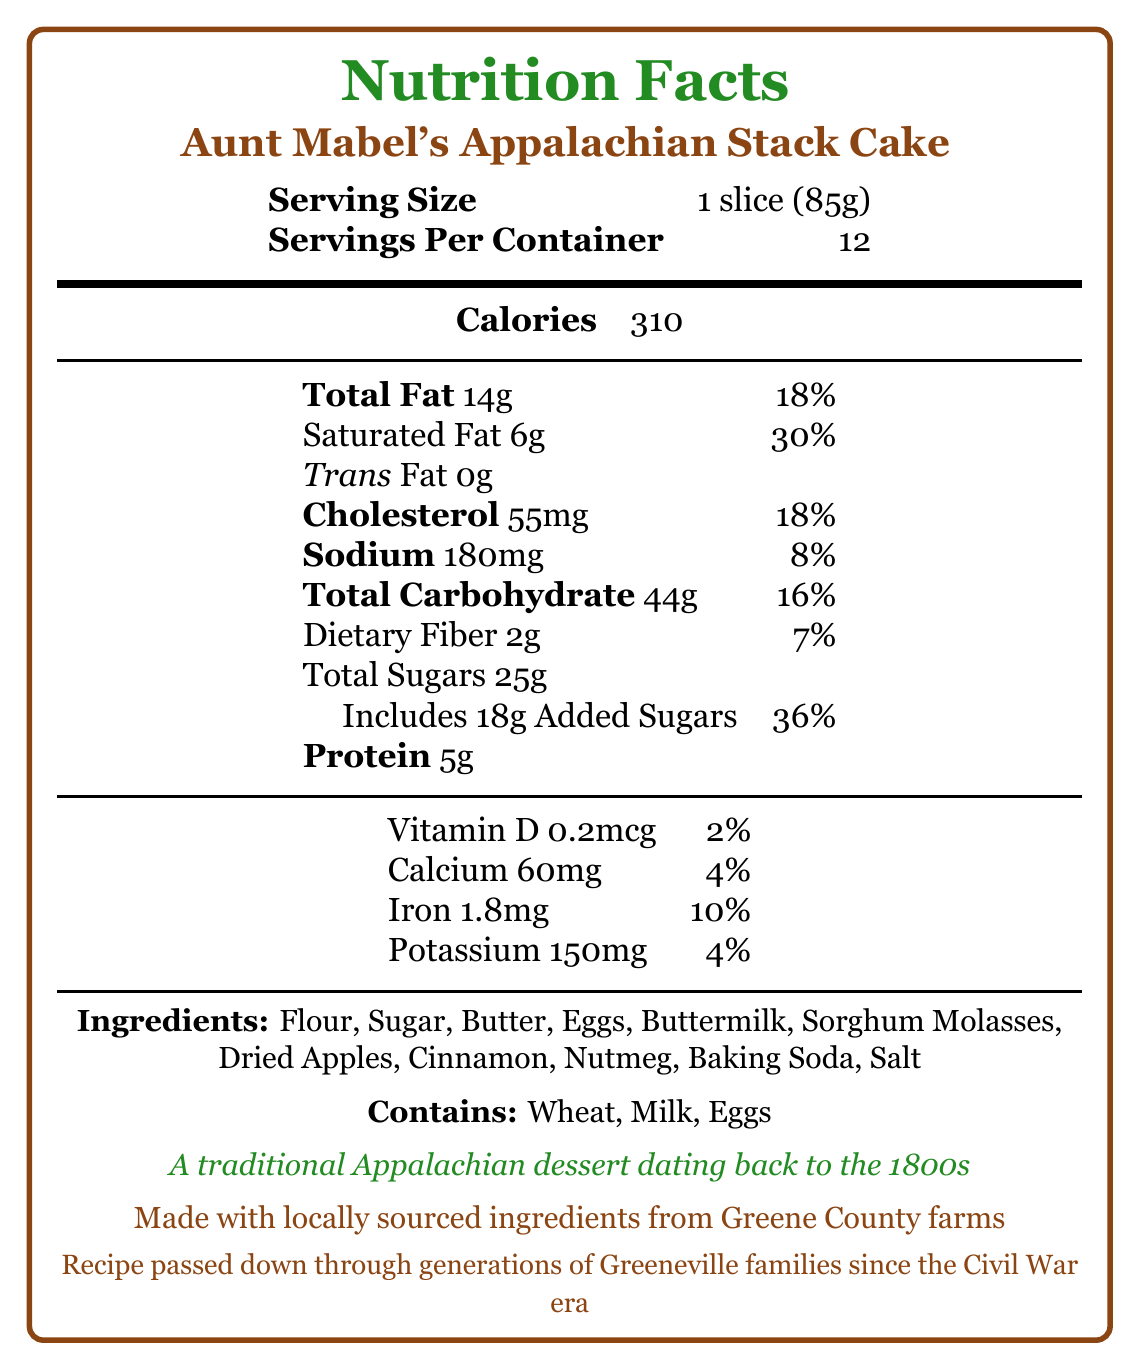what is the serving size? The serving size is explicitly stated as "1 slice (85g)" in the document.
Answer: 1 slice (85g) how many servings are there per container? The document lists "Servings Per Container" as 12.
Answer: 12 how many grams of total fat are in one serving? The document states "Total Fat" as 14g.
Answer: 14g how much dietary fiber does one serving have? The document indicates that "Dietary Fiber" is 2g per serving.
Answer: 2g what percentage of the daily value does the saturated fat in one serving represent? The document shows that the "Saturated Fat" percentage of the daily value is 30%.
Answer: 30% which ingredient gives the cake its distinctive molasses flavor? The ingredient list includes "Sorghum Molasses," which provides the distinctive molasses flavor.
Answer: Sorghum Molasses does the cake contain any trans fat? The document specifies that the "Trans Fat" amount is 0g.
Answer: No summarize the cultural significance of Aunt Mabel's Appalachian Stack Cake. The document describes the cake's deep roots in Appalachian culture and its role in family and community traditions, highlighting its historical and local connection.
Answer: Aunt Mabel's Appalachian Stack Cake is a traditional Appalachian dessert dating back to the 1800s, often served at family gatherings and special occasions. It represents the resourcefulness of early settlers who used preserved fruits and symbolizes community and hospitality in East Tennessee. The cake is made with locally sourced ingredients from Greene County farms, and the recipe has been passed down through generations of Greeneville families since the Civil War era. what is the protein content in one serving of the cake? The document lists the "Protein" content as 5g per serving.
Answer: 5g what are the allergens present in the cake? The document clearly lists allergens as "Contains: Wheat, Milk, Eggs."
Answer: Wheat, Milk, Eggs how much potassium is in one serving of the cake? The document states the "Potassium" content as 150mg per serving.
Answer: 150mg how many grams of added sugars are in one serving? The document specifies that "Added Sugars" amount to 18g per serving.
Answer: 18g is the cake made with ingredients sourced locally? The document mentions that the cake is made with locally sourced ingredients from Greene County farms.
Answer: Yes what is the total carbohydrate content in one slice of the cake? The document lists "Total Carbohydrate" as 44g per serving.
Answer: 44g is the recipe for Aunt Mabel's Appalachian Stack Cake likely to contain preservatives? The document does not provide information about preservatives.
Answer: Cannot be determined how many milligrams of calcium does one serving of the cake provide? The document lists "Calcium" as 60mg per serving.
Answer: 60mg 